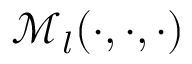<formula> <loc_0><loc_0><loc_500><loc_500>\mathcal { M } _ { l } ( \cdot , \cdot , \cdot )</formula> 